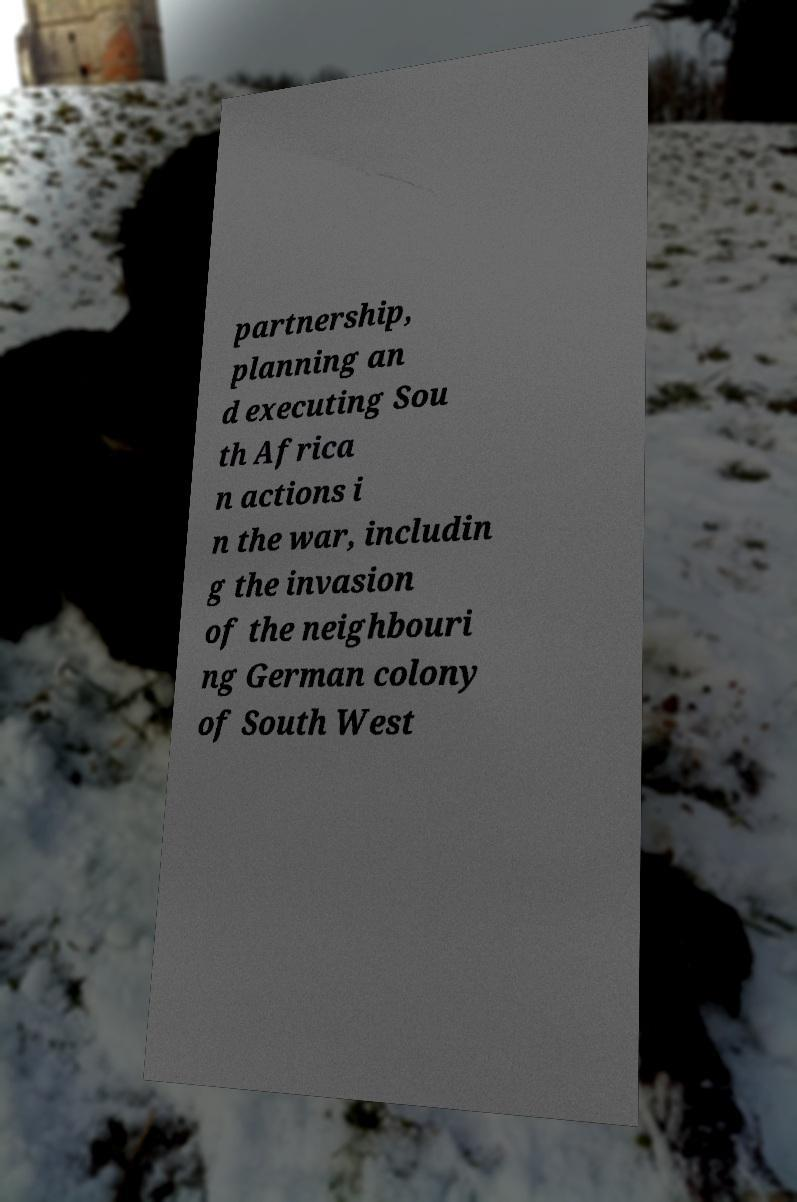There's text embedded in this image that I need extracted. Can you transcribe it verbatim? partnership, planning an d executing Sou th Africa n actions i n the war, includin g the invasion of the neighbouri ng German colony of South West 